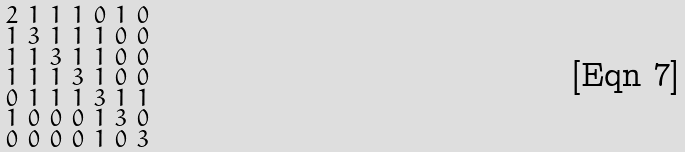<formula> <loc_0><loc_0><loc_500><loc_500>\begin{smallmatrix} 2 & 1 & 1 & 1 & 0 & 1 & 0 \\ 1 & 3 & 1 & 1 & 1 & 0 & 0 \\ 1 & 1 & 3 & 1 & 1 & 0 & 0 \\ 1 & 1 & 1 & 3 & 1 & 0 & 0 \\ 0 & 1 & 1 & 1 & 3 & 1 & 1 \\ 1 & 0 & 0 & 0 & 1 & 3 & 0 \\ 0 & 0 & 0 & 0 & 1 & 0 & 3 \end{smallmatrix}</formula> 